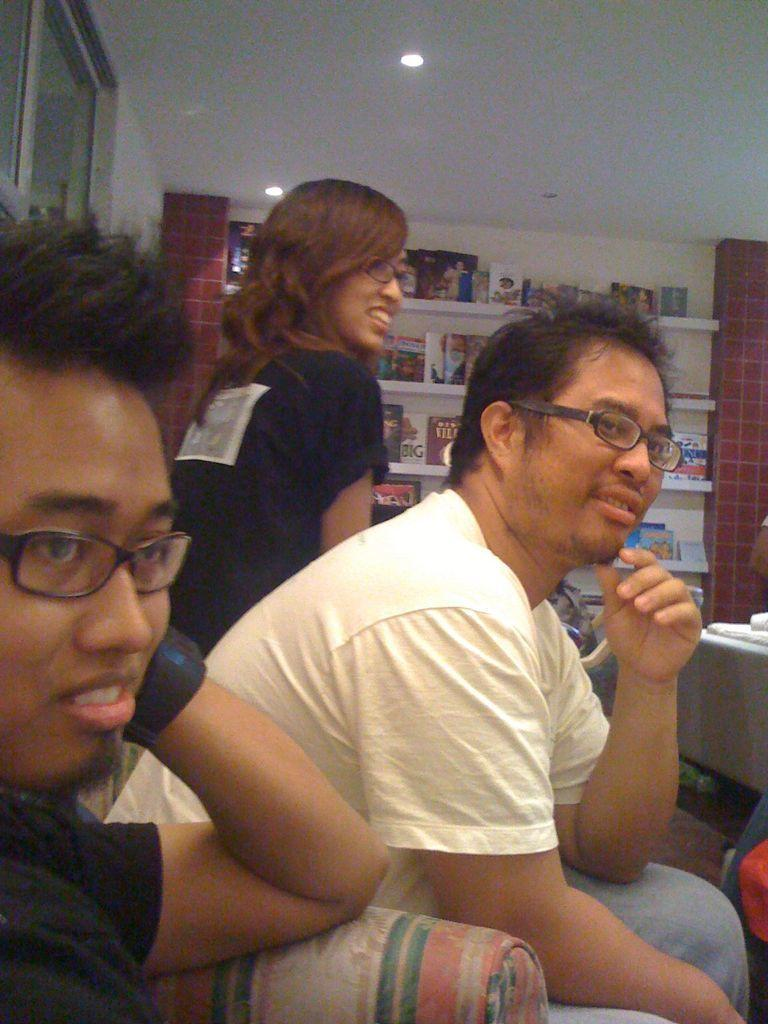What are the people in the image doing? The people in the image are sitting. What can be seen on the faces of the people in the image? The people are wearing spectacles. What can be seen in the background of the image? There are books and objects on shelves in the background of the image. What type of structure is visible in the background of the image? There is a wall in the background of the image. What is a source of natural light visible in the background of the image? There is a window in the background of the image. What is providing illumination at the top of the image? Lights are visible at the top of the image. What type of cork can be seen floating in the cup in the image? There is no cup or cork present in the image. How can the quietness of the room be determined from the image? The image does not provide any information about the noise level or quietness of the room. 